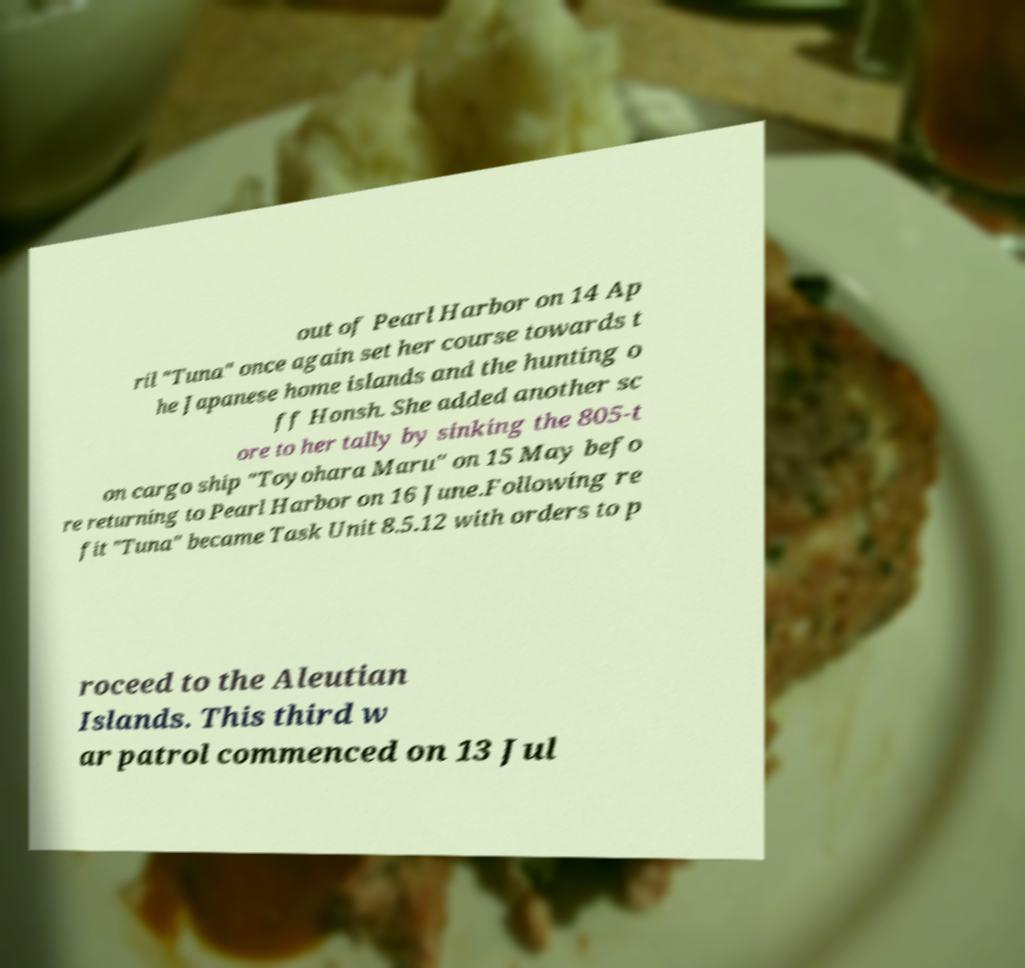Please read and relay the text visible in this image. What does it say? out of Pearl Harbor on 14 Ap ril "Tuna" once again set her course towards t he Japanese home islands and the hunting o ff Honsh. She added another sc ore to her tally by sinking the 805-t on cargo ship "Toyohara Maru" on 15 May befo re returning to Pearl Harbor on 16 June.Following re fit "Tuna" became Task Unit 8.5.12 with orders to p roceed to the Aleutian Islands. This third w ar patrol commenced on 13 Jul 